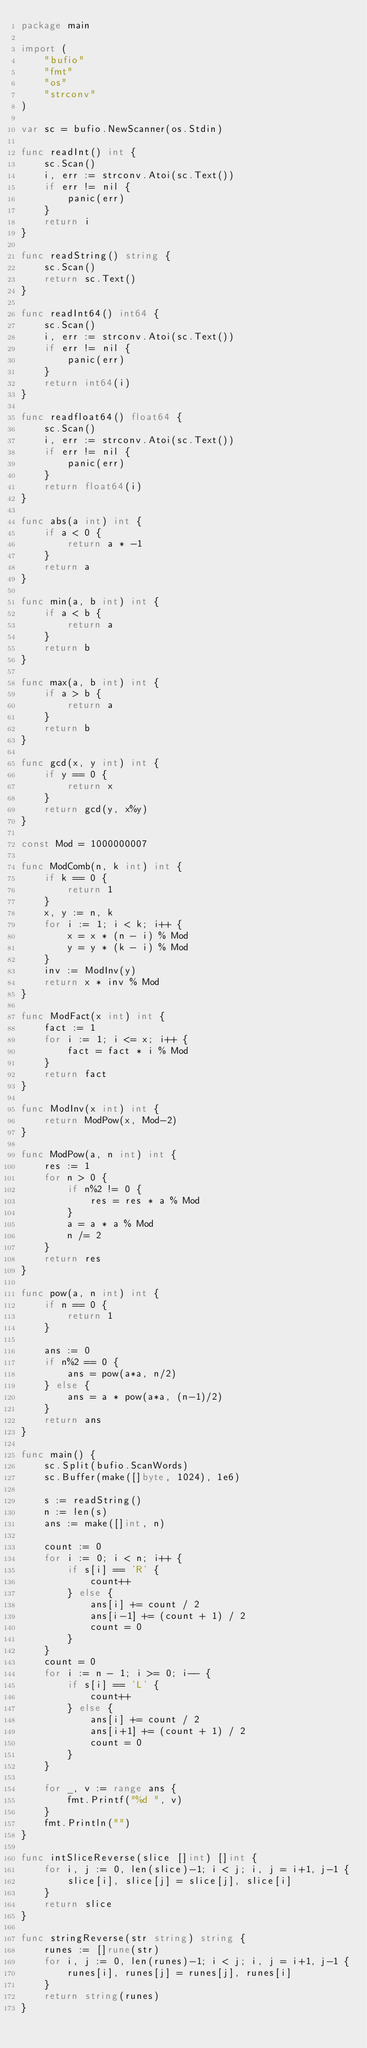<code> <loc_0><loc_0><loc_500><loc_500><_Go_>package main

import (
	"bufio"
	"fmt"
	"os"
	"strconv"
)

var sc = bufio.NewScanner(os.Stdin)

func readInt() int {
	sc.Scan()
	i, err := strconv.Atoi(sc.Text())
	if err != nil {
		panic(err)
	}
	return i
}

func readString() string {
	sc.Scan()
	return sc.Text()
}

func readInt64() int64 {
	sc.Scan()
	i, err := strconv.Atoi(sc.Text())
	if err != nil {
		panic(err)
	}
	return int64(i)
}

func readfloat64() float64 {
	sc.Scan()
	i, err := strconv.Atoi(sc.Text())
	if err != nil {
		panic(err)
	}
	return float64(i)
}

func abs(a int) int {
	if a < 0 {
		return a * -1
	}
	return a
}

func min(a, b int) int {
	if a < b {
		return a
	}
	return b
}

func max(a, b int) int {
	if a > b {
		return a
	}
	return b
}

func gcd(x, y int) int {
	if y == 0 {
		return x
	}
	return gcd(y, x%y)
}

const Mod = 1000000007

func ModComb(n, k int) int {
	if k == 0 {
		return 1
	}
	x, y := n, k
	for i := 1; i < k; i++ {
		x = x * (n - i) % Mod
		y = y * (k - i) % Mod
	}
	inv := ModInv(y)
	return x * inv % Mod
}

func ModFact(x int) int {
	fact := 1
	for i := 1; i <= x; i++ {
		fact = fact * i % Mod
	}
	return fact
}

func ModInv(x int) int {
	return ModPow(x, Mod-2)
}

func ModPow(a, n int) int {
	res := 1
	for n > 0 {
		if n%2 != 0 {
			res = res * a % Mod
		}
		a = a * a % Mod
		n /= 2
	}
	return res
}

func pow(a, n int) int {
	if n == 0 {
		return 1
	}

	ans := 0
	if n%2 == 0 {
		ans = pow(a*a, n/2)
	} else {
		ans = a * pow(a*a, (n-1)/2)
	}
	return ans
}

func main() {
	sc.Split(bufio.ScanWords)
	sc.Buffer(make([]byte, 1024), 1e6)

	s := readString()
	n := len(s)
	ans := make([]int, n)

	count := 0
	for i := 0; i < n; i++ {
		if s[i] == 'R' {
			count++
		} else {
			ans[i] += count / 2
			ans[i-1] += (count + 1) / 2
			count = 0
		}
	}
	count = 0
	for i := n - 1; i >= 0; i-- {
		if s[i] == 'L' {
			count++
		} else {
			ans[i] += count / 2
			ans[i+1] += (count + 1) / 2
			count = 0
		}
	}

	for _, v := range ans {
		fmt.Printf("%d ", v)
	}
	fmt.Println("")
}

func intSliceReverse(slice []int) []int {
	for i, j := 0, len(slice)-1; i < j; i, j = i+1, j-1 {
		slice[i], slice[j] = slice[j], slice[i]
	}
	return slice
}

func stringReverse(str string) string {
	runes := []rune(str)
	for i, j := 0, len(runes)-1; i < j; i, j = i+1, j-1 {
		runes[i], runes[j] = runes[j], runes[i]
	}
	return string(runes)
}
</code> 